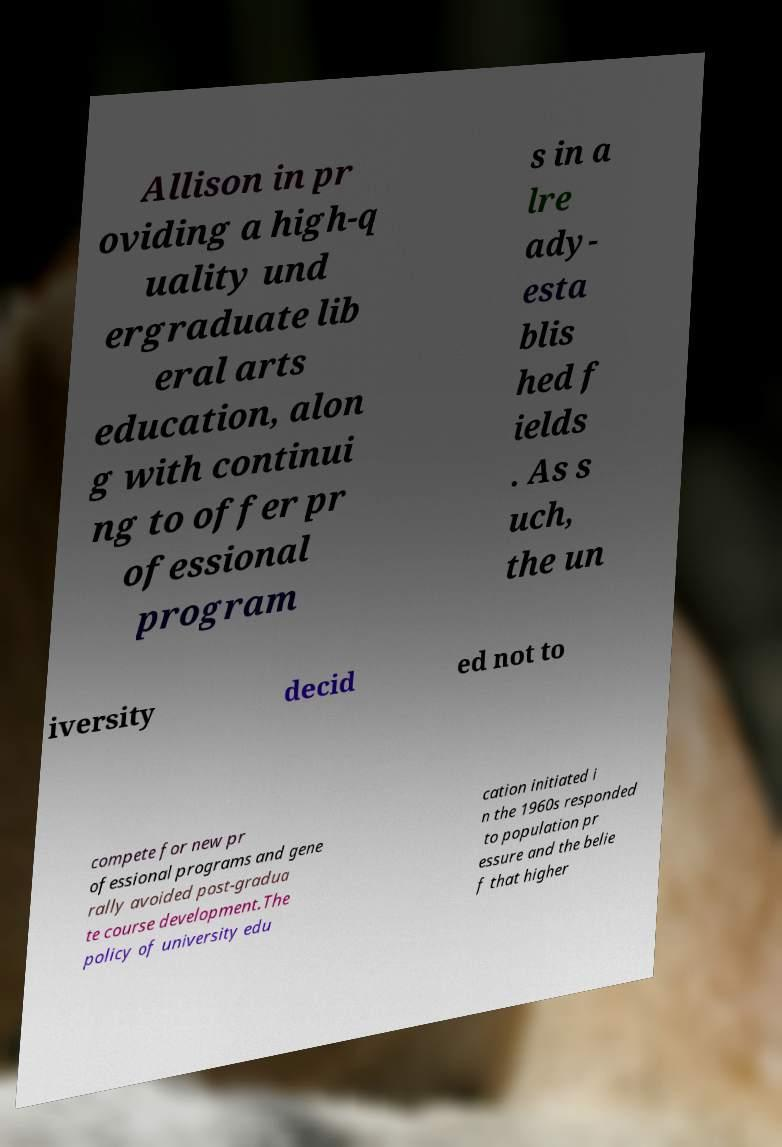For documentation purposes, I need the text within this image transcribed. Could you provide that? Allison in pr oviding a high-q uality und ergraduate lib eral arts education, alon g with continui ng to offer pr ofessional program s in a lre ady- esta blis hed f ields . As s uch, the un iversity decid ed not to compete for new pr ofessional programs and gene rally avoided post-gradua te course development.The policy of university edu cation initiated i n the 1960s responded to population pr essure and the belie f that higher 